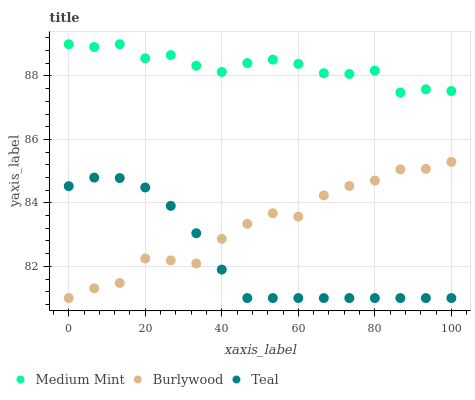Does Teal have the minimum area under the curve?
Answer yes or no. Yes. Does Medium Mint have the maximum area under the curve?
Answer yes or no. Yes. Does Burlywood have the minimum area under the curve?
Answer yes or no. No. Does Burlywood have the maximum area under the curve?
Answer yes or no. No. Is Teal the smoothest?
Answer yes or no. Yes. Is Burlywood the roughest?
Answer yes or no. Yes. Is Burlywood the smoothest?
Answer yes or no. No. Is Teal the roughest?
Answer yes or no. No. Does Burlywood have the lowest value?
Answer yes or no. Yes. Does Medium Mint have the highest value?
Answer yes or no. Yes. Does Burlywood have the highest value?
Answer yes or no. No. Is Burlywood less than Medium Mint?
Answer yes or no. Yes. Is Medium Mint greater than Burlywood?
Answer yes or no. Yes. Does Burlywood intersect Teal?
Answer yes or no. Yes. Is Burlywood less than Teal?
Answer yes or no. No. Is Burlywood greater than Teal?
Answer yes or no. No. Does Burlywood intersect Medium Mint?
Answer yes or no. No. 